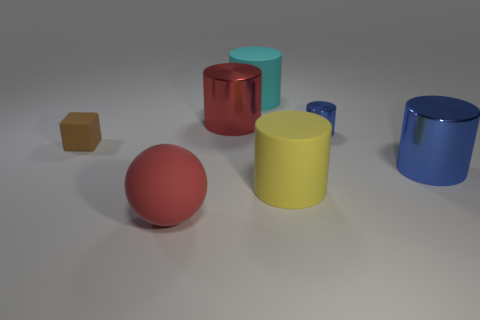How many cylinders are either brown rubber things or large metal things?
Give a very brief answer. 2. What number of things are made of the same material as the red cylinder?
Your answer should be very brief. 2. There is a large thing that is the same color as the big rubber sphere; what shape is it?
Offer a terse response. Cylinder. There is a big object that is both to the right of the big matte sphere and in front of the big blue metal object; what material is it made of?
Keep it short and to the point. Rubber. What shape is the matte thing that is behind the small metal cylinder?
Ensure brevity in your answer.  Cylinder. There is a big matte thing on the left side of the big matte cylinder behind the red cylinder; what shape is it?
Offer a very short reply. Sphere. Is there a big yellow object that has the same shape as the tiny rubber object?
Make the answer very short. No. There is a blue thing that is the same size as the cyan matte cylinder; what is its shape?
Keep it short and to the point. Cylinder. There is a matte object that is behind the metal thing left of the large cyan cylinder; are there any cylinders that are left of it?
Keep it short and to the point. Yes. Is there another matte object of the same size as the brown object?
Your response must be concise. No. 